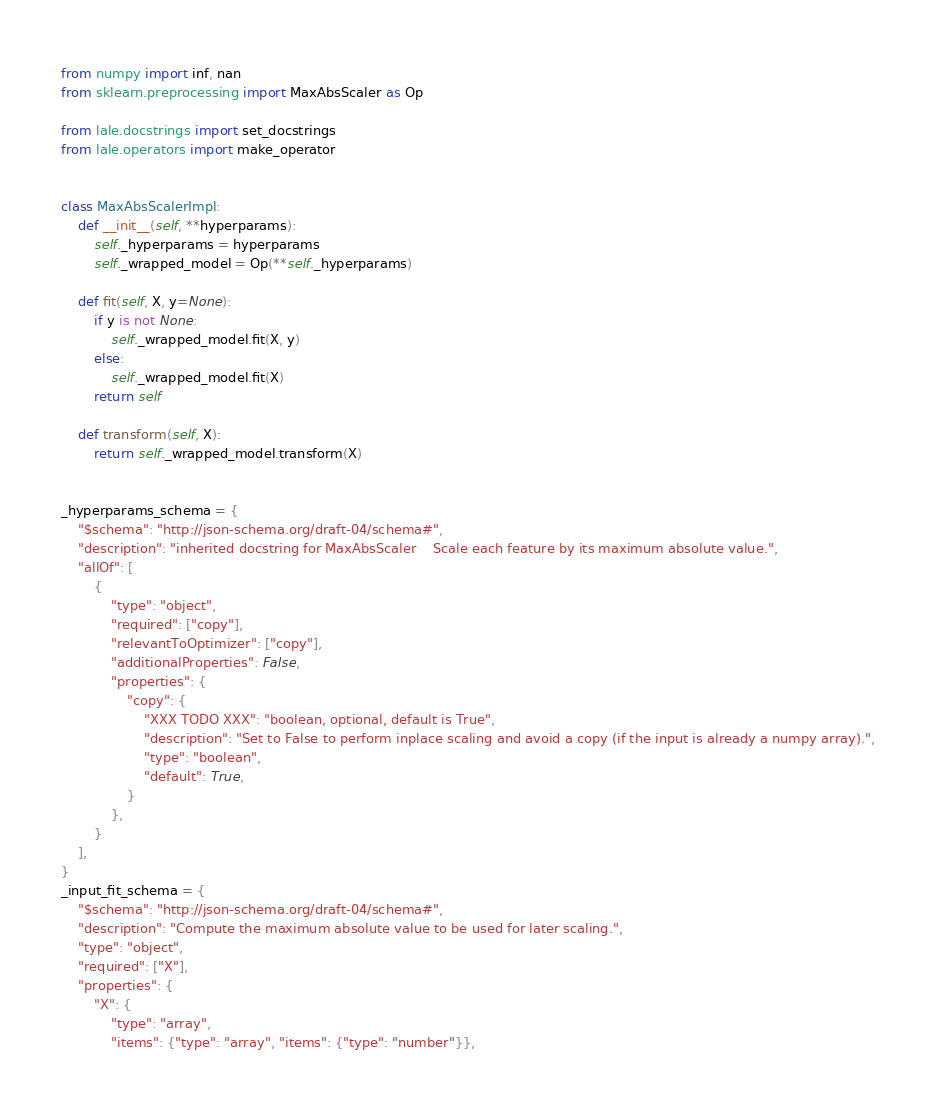Convert code to text. <code><loc_0><loc_0><loc_500><loc_500><_Python_>from numpy import inf, nan
from sklearn.preprocessing import MaxAbsScaler as Op

from lale.docstrings import set_docstrings
from lale.operators import make_operator


class MaxAbsScalerImpl:
    def __init__(self, **hyperparams):
        self._hyperparams = hyperparams
        self._wrapped_model = Op(**self._hyperparams)

    def fit(self, X, y=None):
        if y is not None:
            self._wrapped_model.fit(X, y)
        else:
            self._wrapped_model.fit(X)
        return self

    def transform(self, X):
        return self._wrapped_model.transform(X)


_hyperparams_schema = {
    "$schema": "http://json-schema.org/draft-04/schema#",
    "description": "inherited docstring for MaxAbsScaler    Scale each feature by its maximum absolute value.",
    "allOf": [
        {
            "type": "object",
            "required": ["copy"],
            "relevantToOptimizer": ["copy"],
            "additionalProperties": False,
            "properties": {
                "copy": {
                    "XXX TODO XXX": "boolean, optional, default is True",
                    "description": "Set to False to perform inplace scaling and avoid a copy (if the input is already a numpy array).",
                    "type": "boolean",
                    "default": True,
                }
            },
        }
    ],
}
_input_fit_schema = {
    "$schema": "http://json-schema.org/draft-04/schema#",
    "description": "Compute the maximum absolute value to be used for later scaling.",
    "type": "object",
    "required": ["X"],
    "properties": {
        "X": {
            "type": "array",
            "items": {"type": "array", "items": {"type": "number"}},</code> 